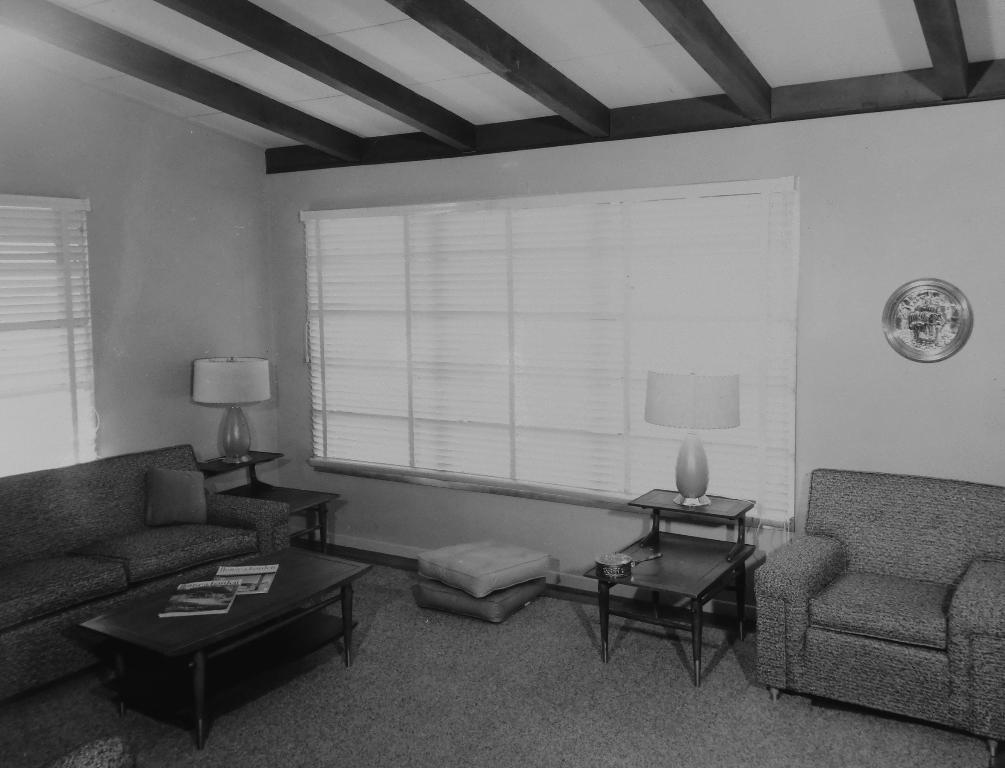What type of furniture is present in the image? There is a couch, a pillow, a table, and a chair in the image. What is on the table in the image? There are books and a lamp on the table in the image. What is visible at the back side of the image? There is a window and a wall at the back side of the image. What type of dock can be seen in the image? There is no dock present in the image. What kind of lunch is being served on the table in the image? There is no lunch visible in the image; it only shows books and a lamp on the table. 